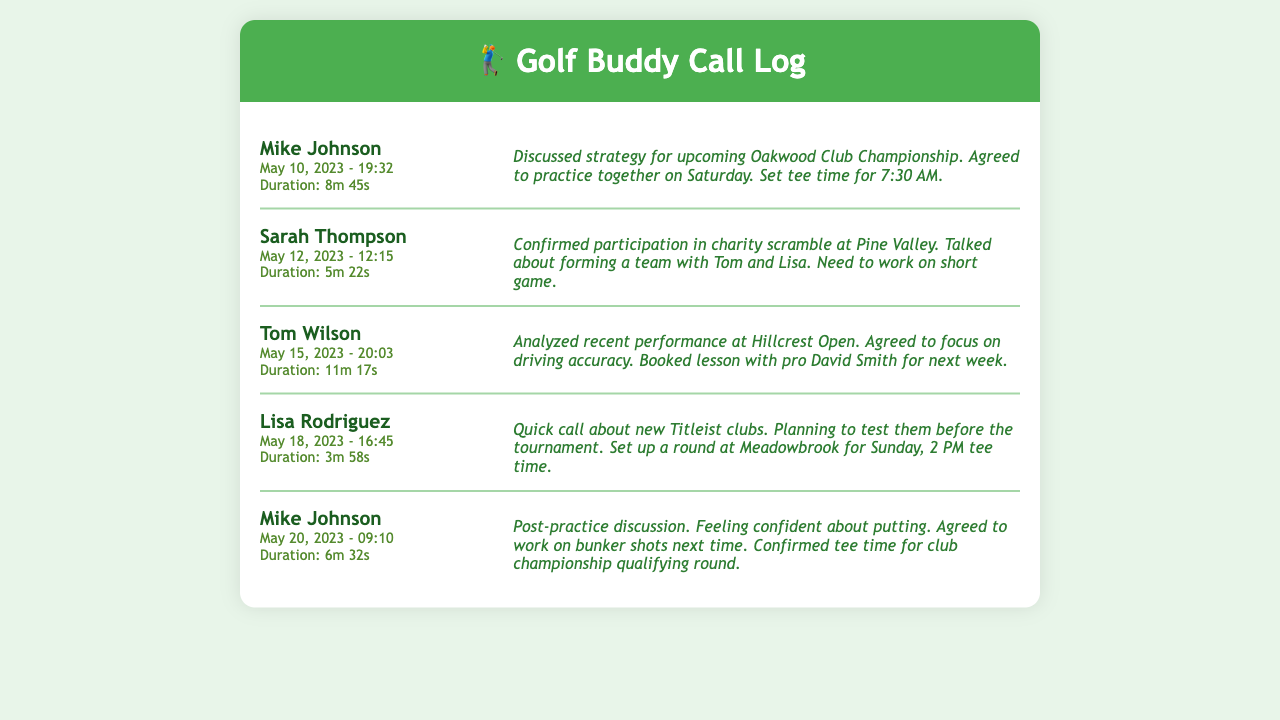What was the date of the call with Mike Johnson? The date of the call with Mike Johnson is mentioned in the document as May 10, 2023.
Answer: May 10, 2023 What was the duration of the call with Sarah Thompson? The duration of the call with Sarah Thompson is displayed as 5m 22s.
Answer: 5m 22s What tee time did Mike and his buddies set for the practice? The tee time set for the practice is specified in the call notes as 7:30 AM.
Answer: 7:30 AM Who did Sarah Thompson plan to form a team with? Sarah Thompson mentioned forming a team with Tom and Lisa in her conversation.
Answer: Tom and Lisa What specific area did Tom Wilson decide to focus on for improvement? Tom Wilson agreed to focus on driving accuracy during their conversation.
Answer: Driving accuracy How long was the call with Lisa Rodriguez? The duration of the call with Lisa Rodriguez is stated as 3m 58s.
Answer: 3m 58s What golf clubs did Lisa mention in her call? Lisa Rodriguez discussed new Titleist clubs during her phone call.
Answer: Titleist clubs When is the next practice session scheduled with Mike? Mike and his buddies agreed to practice together on Saturday after their conversation.
Answer: Saturday Which championship did the group discuss? The group discussed the Oakwood Club Championship during their conversation.
Answer: Oakwood Club Championship 